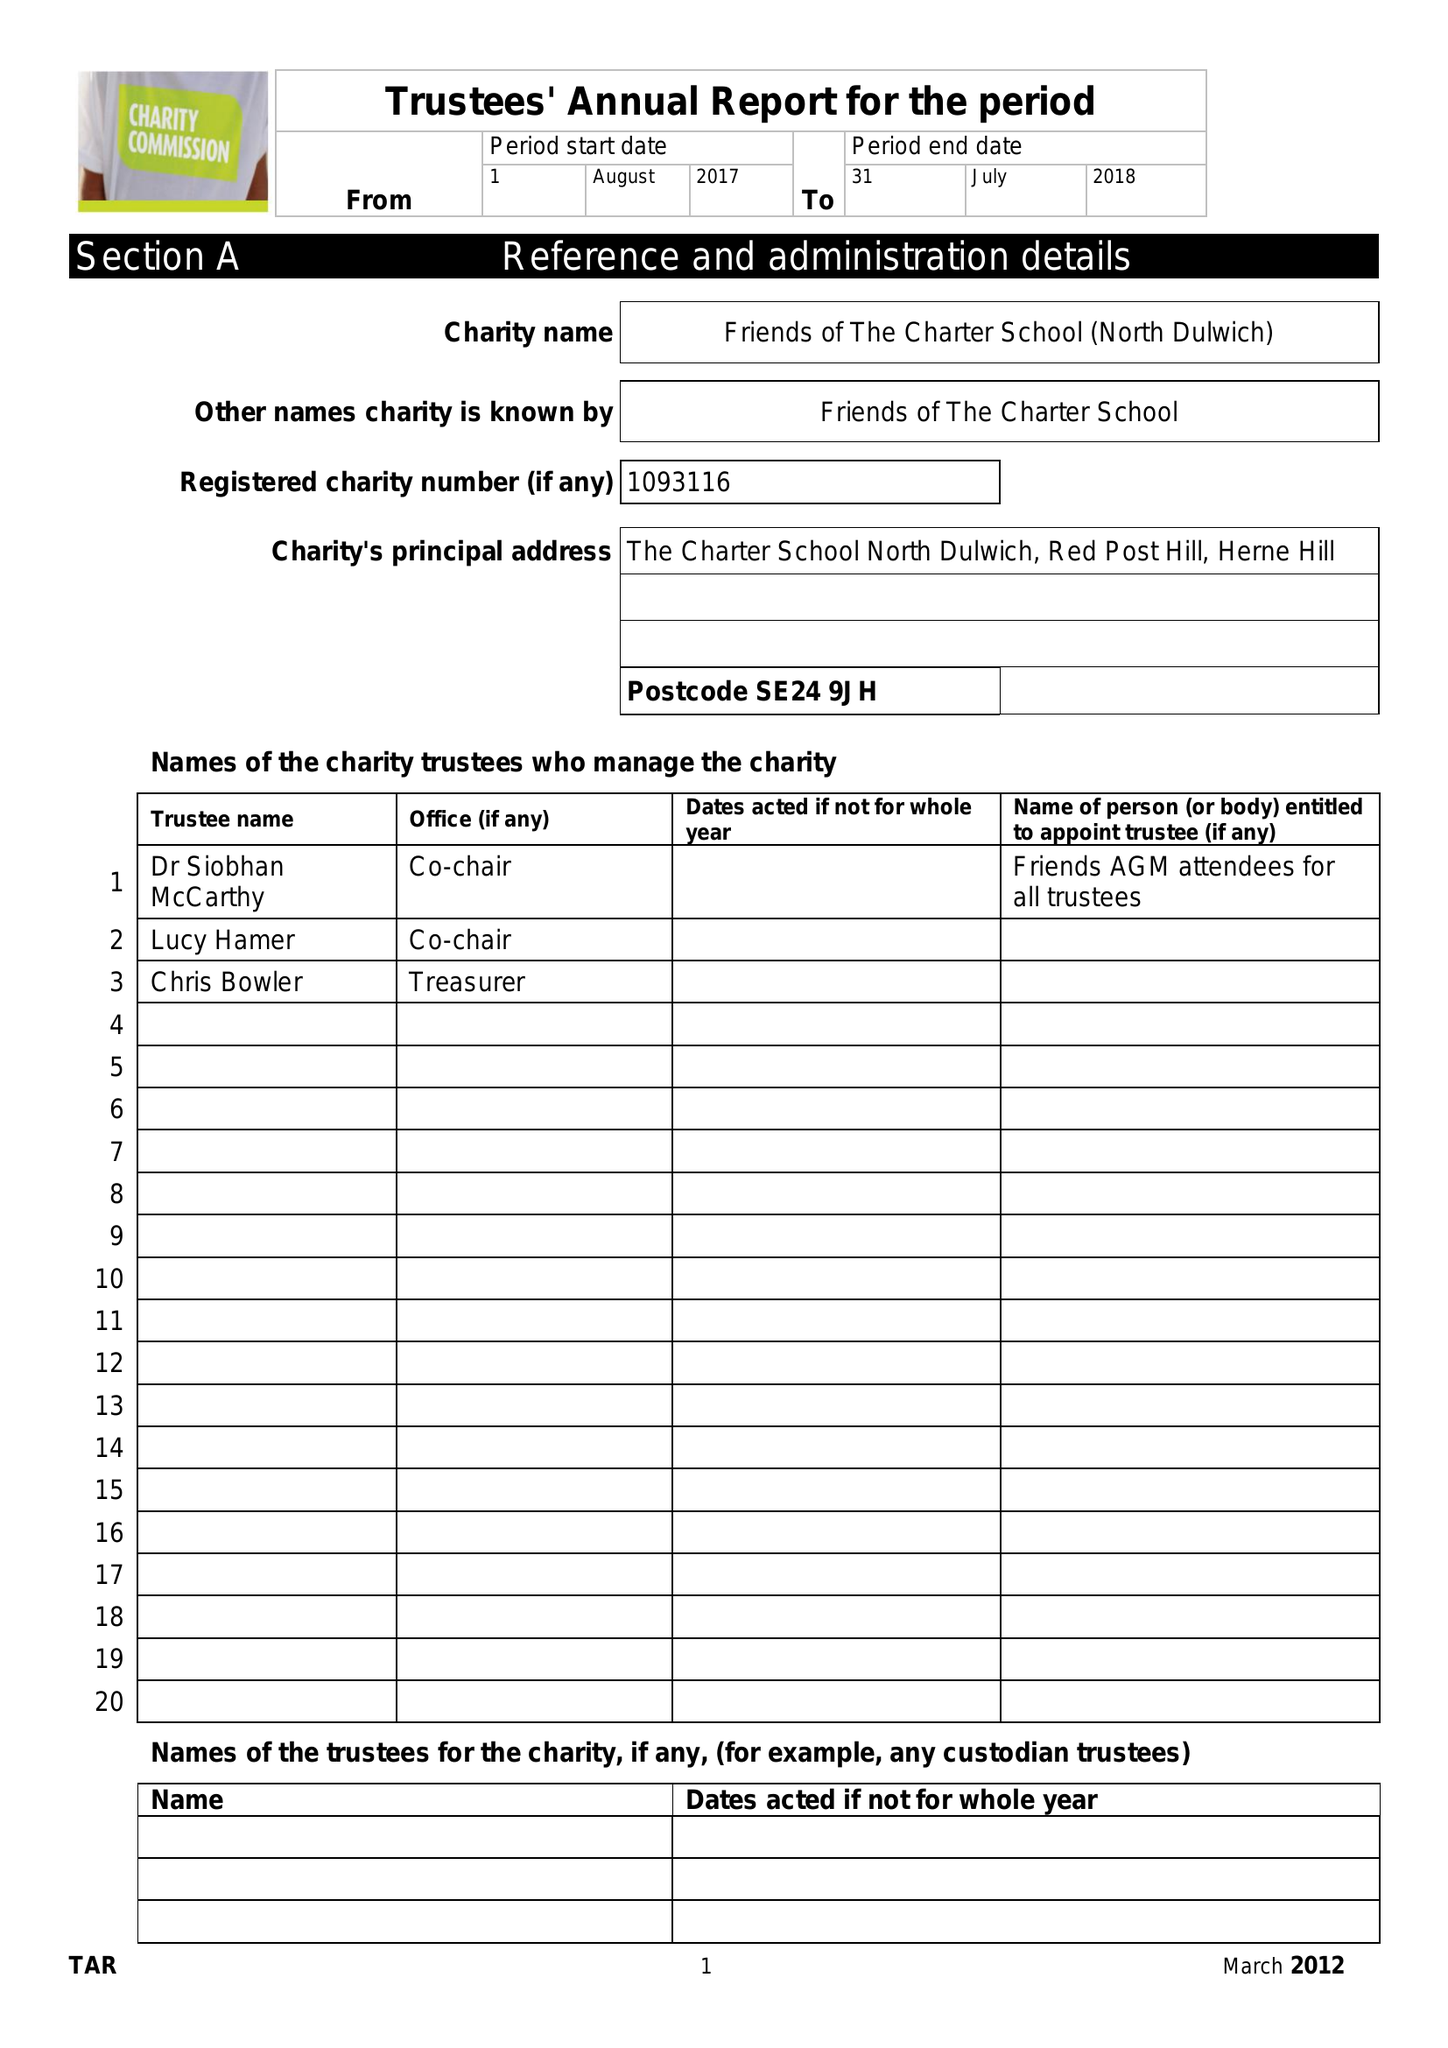What is the value for the income_annually_in_british_pounds?
Answer the question using a single word or phrase. 43152.00 